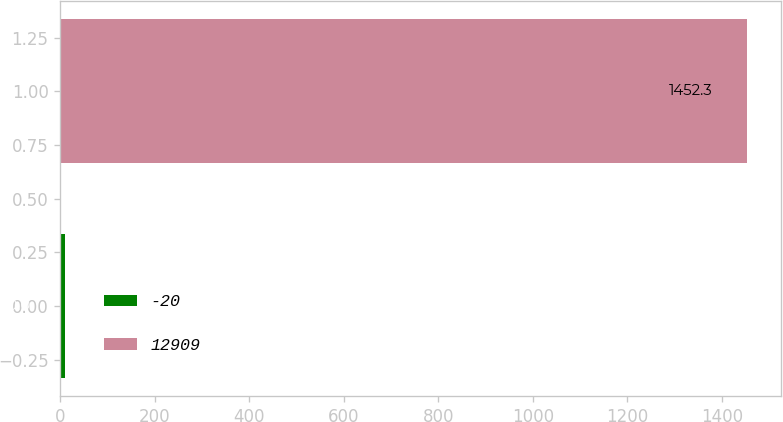Convert chart to OTSL. <chart><loc_0><loc_0><loc_500><loc_500><bar_chart><fcel>-20<fcel>12909<nl><fcel>10<fcel>1452.3<nl></chart> 